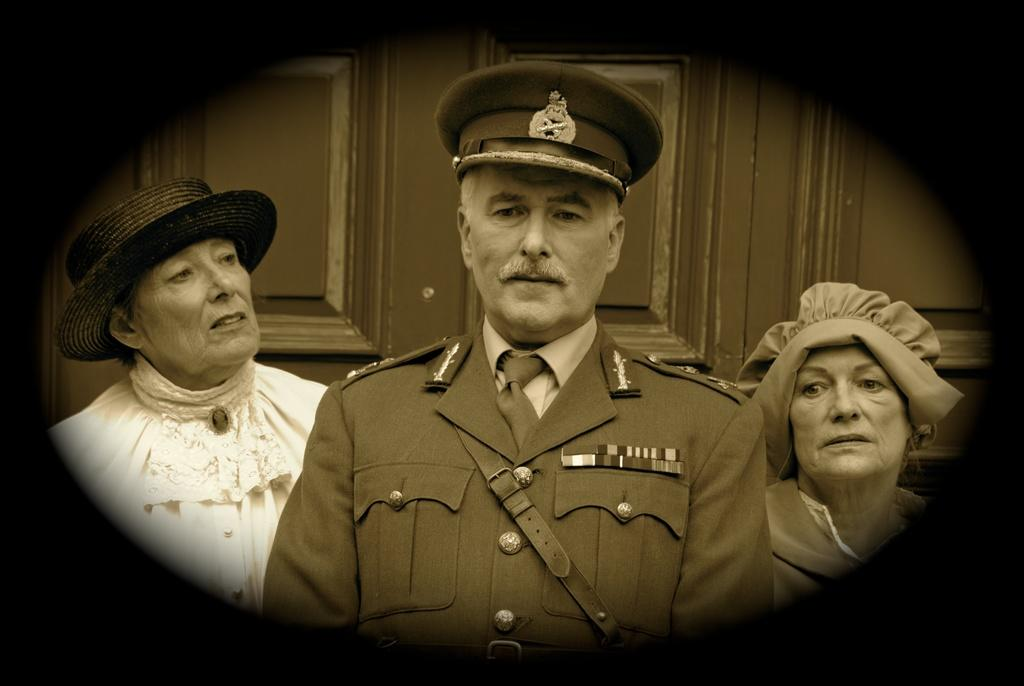How many people are present in the image? There are three people in the image: one man and two women. Where is the man located in the image? The man is in the middle of the image. What is the position of the women in relation to the man? The women are on either side of the man. Can you describe any architectural features in the image? Yes, there is a door in the image. What type of bulb is hanging from the ceiling in the image? There is no bulb visible in the image; it only features a man, two women, and a door. 